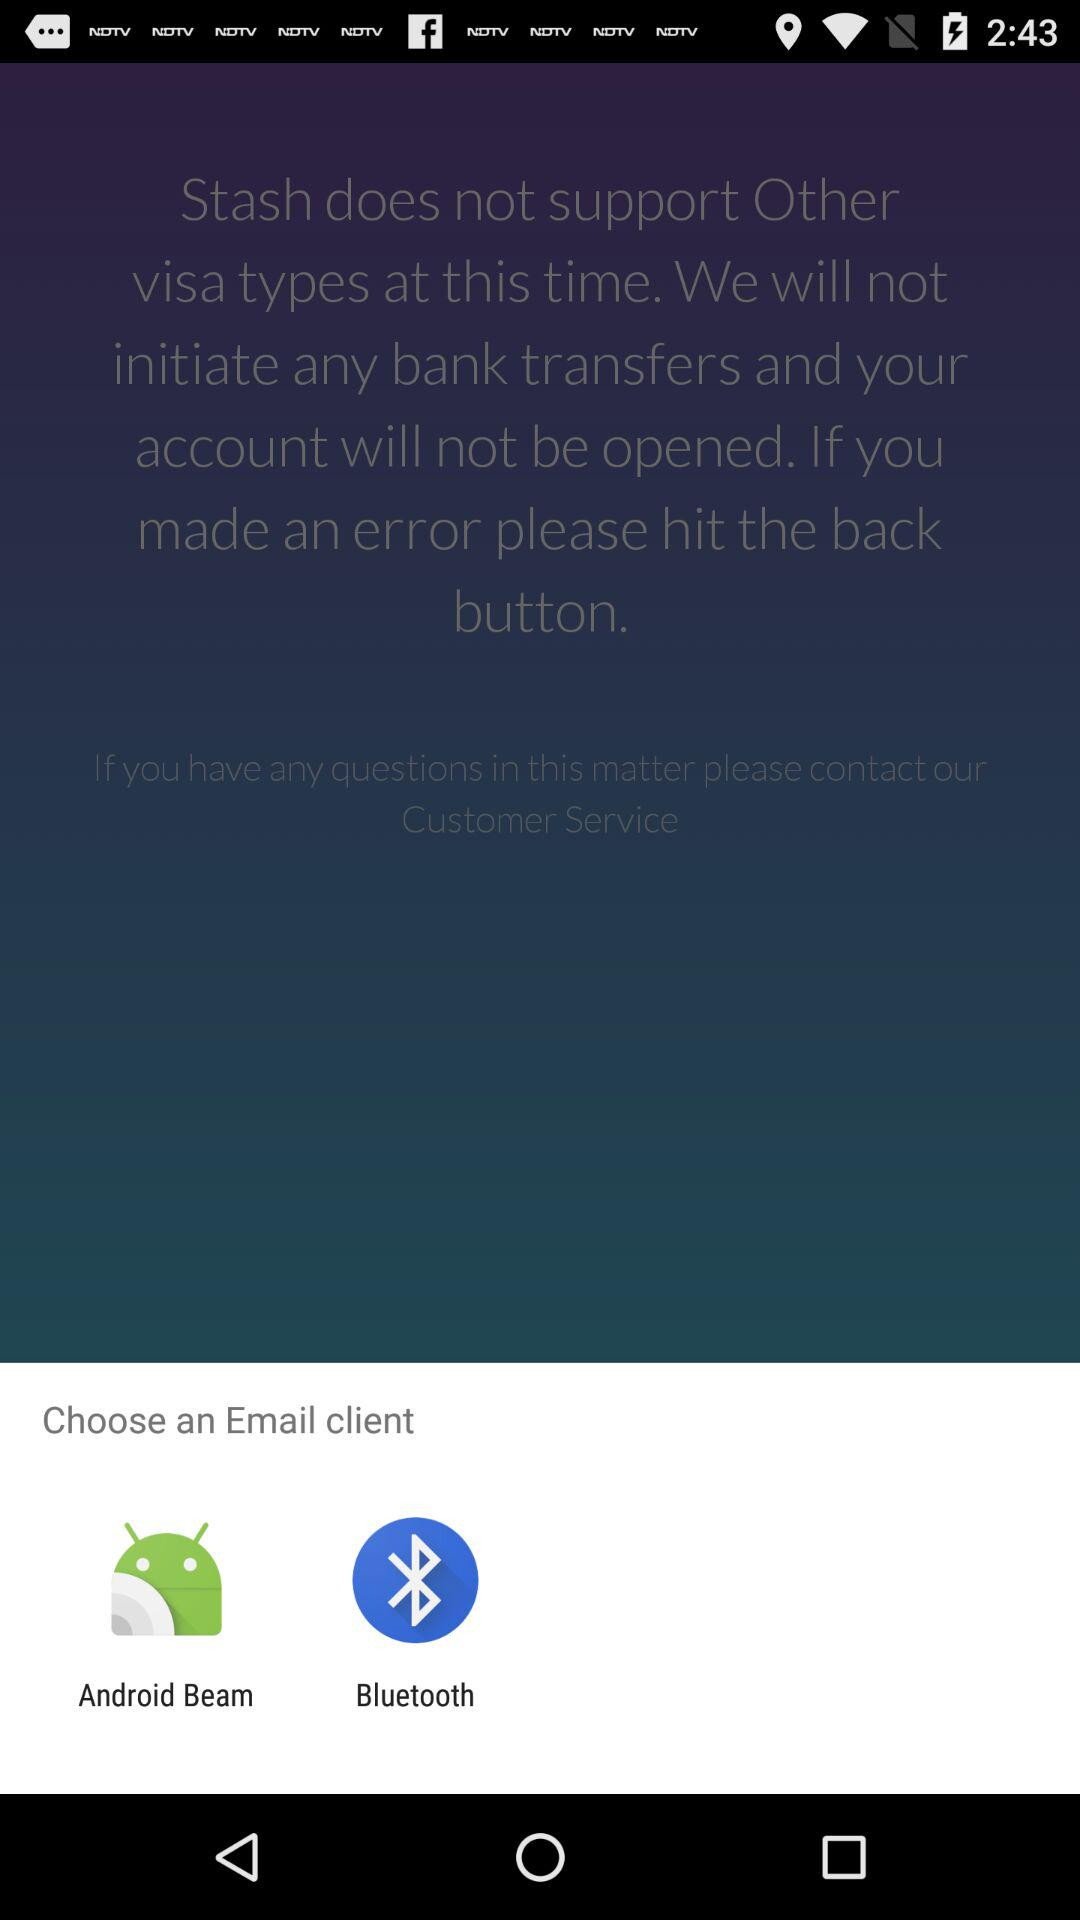What are the options given to choose an email client? The options are "Android Beam" and "Bluetooth". 